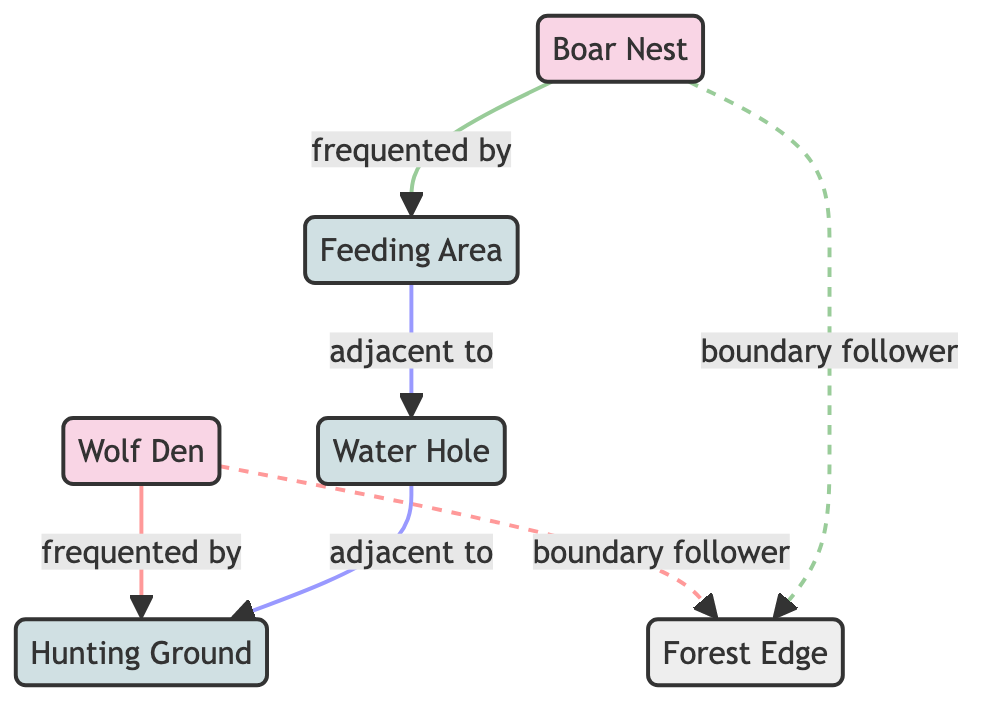What is the main shelter for the wolf pack? The node labeled "Wolf Den" represents the main shelter and living area for the wolf pack, according to the description provided in the diagram.
Answer: Wolf Den How many interaction zones are present in the diagram? By counting the nodes designated as interaction zones, we find three: Water Hole, Hunting Ground, and Feeding Area.
Answer: 3 Which area is frequently visited by the boar family? The feeding area is directly connected to the boar nest with the relationship labeled "frequented by," indicating that the boar family frequently visits this area.
Answer: Feeding Area What two areas are adjacent to the water hole? The water hole is connected to both the hunting ground and the feeding area as adjacent zones, which shows their proximity to the water hole in the diagram.
Answer: Hunting Ground, Feeding Area Do both the wolf den and boar nest patrol the forest edge? Yes, both the wolf den and the boar nest are connected to the forest edge with the "boundary follower" relationship, indicating that they both patrol this natural boundary.
Answer: Yes Which zone is rich in prey? The hunting ground is specifically described as an area rich in prey, frequently visited by wolves from the den, highlighting its importance in the ecosystem depicted.
Answer: Hunting Ground What type of boundary is the forest edge classified as? The forest edge is classified as a "natural boundary" in the diagram, thus indicating its environmental significance separating different habitats.
Answer: Natural Boundary Which family is likely to encounter the other at the water hole? Given that the water hole is an interaction zone and serves as a common water source, it is likely that both the wolves and boars may encounter each other there.
Answer: Both families How are the feeding area and the water hole related? The feeding area is connected to the water hole with the relationship labeled "adjacent to," indicating their close spatial relationship in the ecosystem.
Answer: Adjacent To 